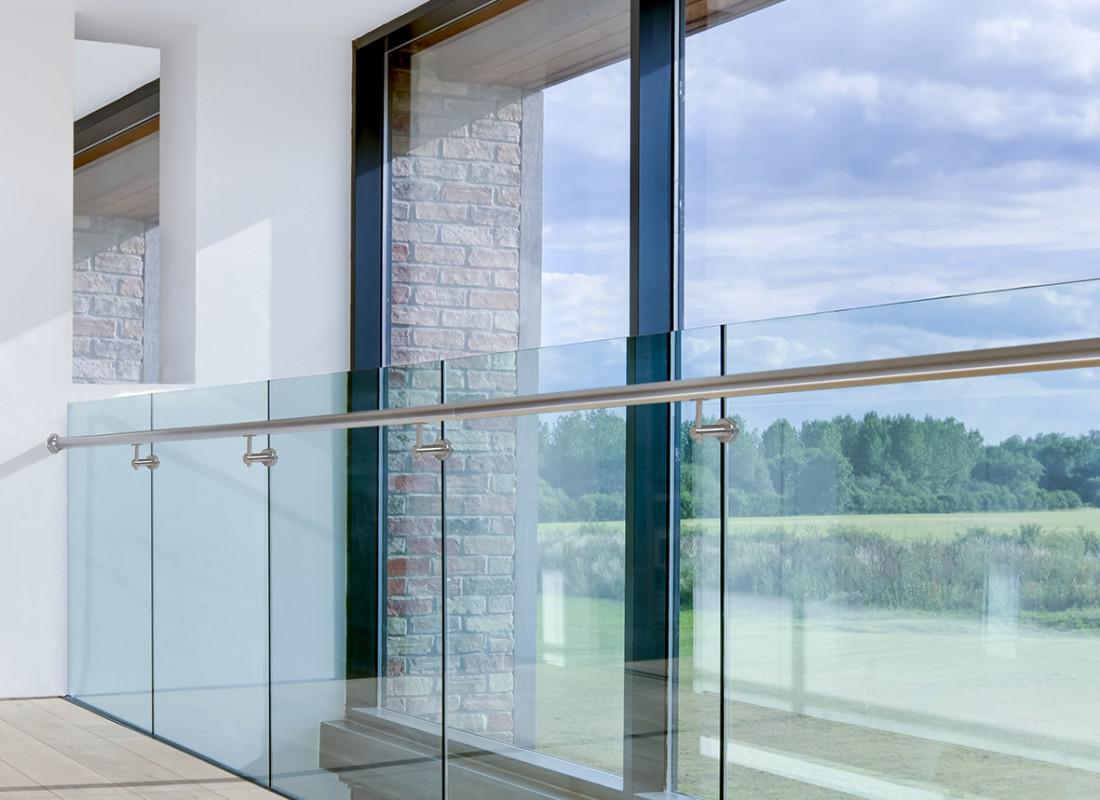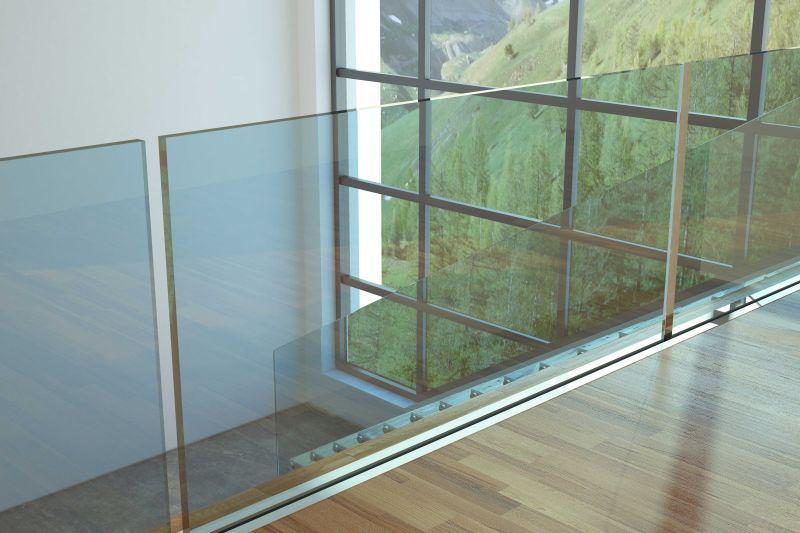The first image is the image on the left, the second image is the image on the right. For the images displayed, is the sentence "A building with at least 3 stories has glass deck railings outside." factually correct? Answer yes or no. No. The first image is the image on the left, the second image is the image on the right. Considering the images on both sides, is "The right image contains at least three balconies on a building." valid? Answer yes or no. No. 